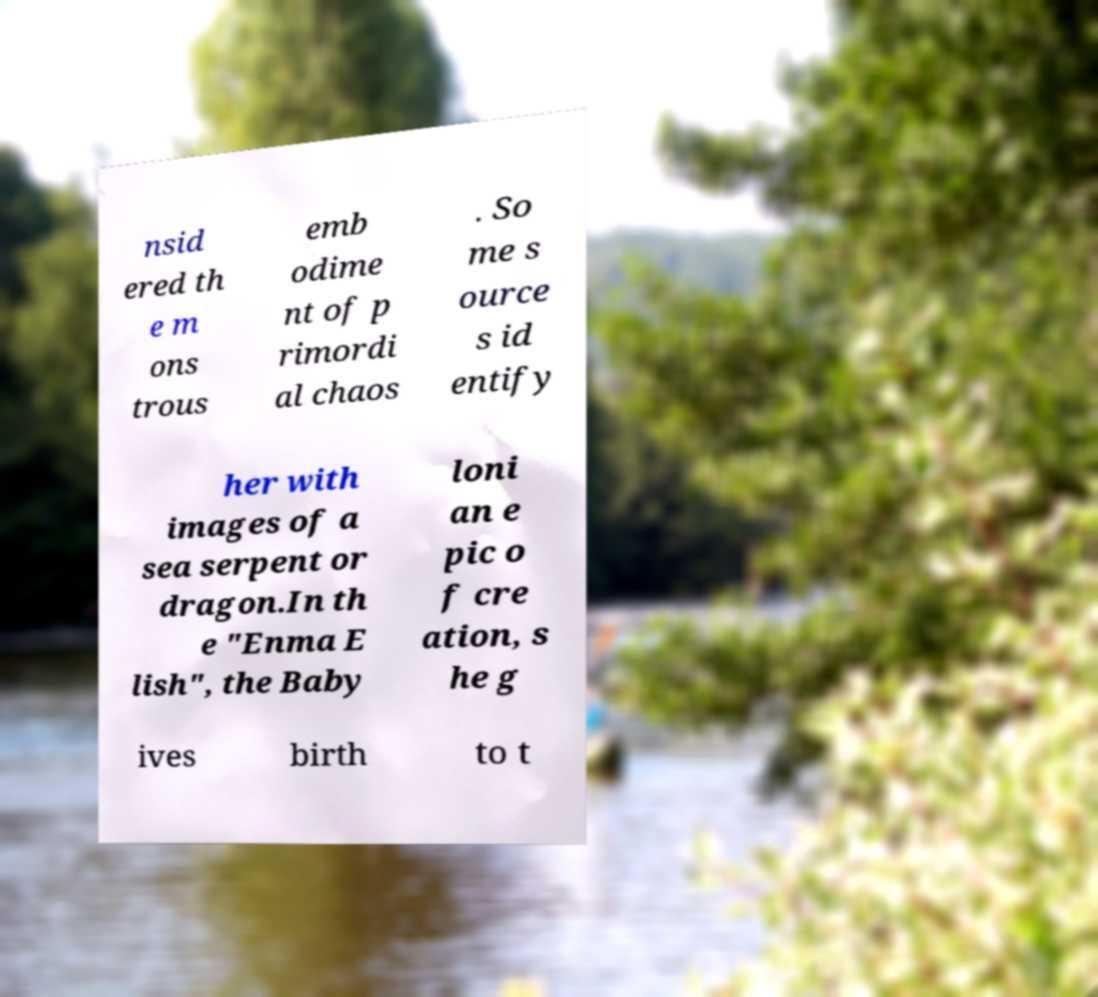Can you accurately transcribe the text from the provided image for me? nsid ered th e m ons trous emb odime nt of p rimordi al chaos . So me s ource s id entify her with images of a sea serpent or dragon.In th e "Enma E lish", the Baby loni an e pic o f cre ation, s he g ives birth to t 